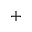Convert formula to latex. <formula><loc_0><loc_0><loc_500><loc_500>+</formula> 